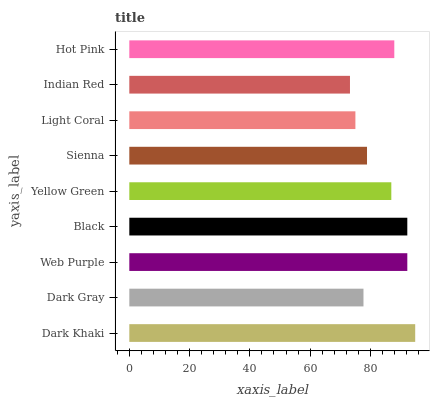Is Indian Red the minimum?
Answer yes or no. Yes. Is Dark Khaki the maximum?
Answer yes or no. Yes. Is Dark Gray the minimum?
Answer yes or no. No. Is Dark Gray the maximum?
Answer yes or no. No. Is Dark Khaki greater than Dark Gray?
Answer yes or no. Yes. Is Dark Gray less than Dark Khaki?
Answer yes or no. Yes. Is Dark Gray greater than Dark Khaki?
Answer yes or no. No. Is Dark Khaki less than Dark Gray?
Answer yes or no. No. Is Yellow Green the high median?
Answer yes or no. Yes. Is Yellow Green the low median?
Answer yes or no. Yes. Is Dark Gray the high median?
Answer yes or no. No. Is Dark Khaki the low median?
Answer yes or no. No. 